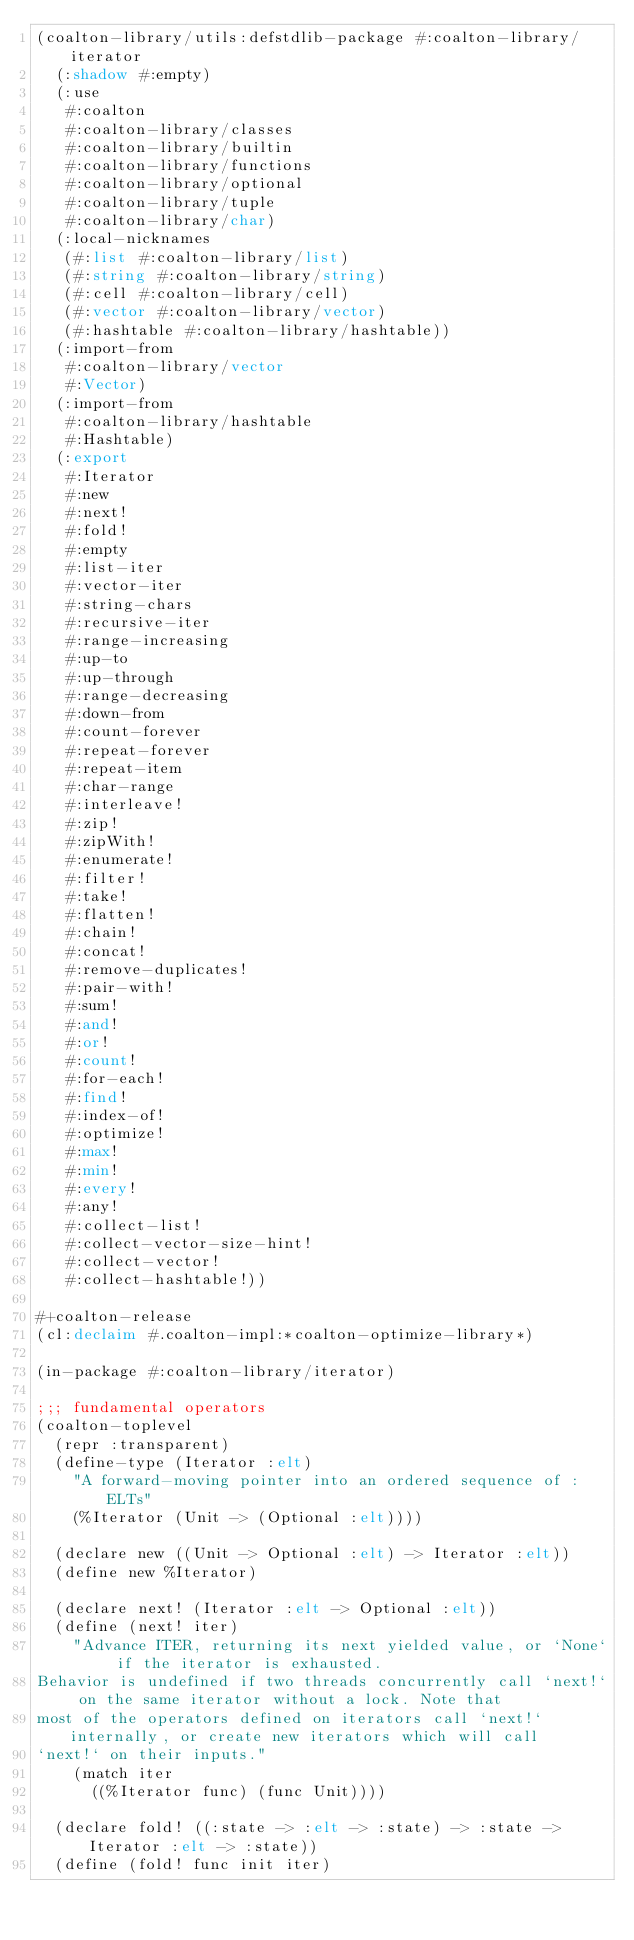<code> <loc_0><loc_0><loc_500><loc_500><_Lisp_>(coalton-library/utils:defstdlib-package #:coalton-library/iterator
  (:shadow #:empty)
  (:use
   #:coalton
   #:coalton-library/classes
   #:coalton-library/builtin
   #:coalton-library/functions
   #:coalton-library/optional
   #:coalton-library/tuple
   #:coalton-library/char)
  (:local-nicknames
   (#:list #:coalton-library/list)
   (#:string #:coalton-library/string)
   (#:cell #:coalton-library/cell)
   (#:vector #:coalton-library/vector)
   (#:hashtable #:coalton-library/hashtable))
  (:import-from
   #:coalton-library/vector
   #:Vector)
  (:import-from
   #:coalton-library/hashtable
   #:Hashtable)
  (:export
   #:Iterator
   #:new
   #:next!
   #:fold!
   #:empty
   #:list-iter
   #:vector-iter
   #:string-chars
   #:recursive-iter
   #:range-increasing
   #:up-to
   #:up-through
   #:range-decreasing
   #:down-from
   #:count-forever
   #:repeat-forever
   #:repeat-item
   #:char-range
   #:interleave!
   #:zip!
   #:zipWith!
   #:enumerate!
   #:filter!
   #:take!
   #:flatten!
   #:chain!
   #:concat!
   #:remove-duplicates!
   #:pair-with!
   #:sum!
   #:and!
   #:or!
   #:count!
   #:for-each!
   #:find!
   #:index-of!
   #:optimize!
   #:max!
   #:min!
   #:every!
   #:any!
   #:collect-list!
   #:collect-vector-size-hint!
   #:collect-vector!
   #:collect-hashtable!))

#+coalton-release
(cl:declaim #.coalton-impl:*coalton-optimize-library*)

(in-package #:coalton-library/iterator)

;;; fundamental operators
(coalton-toplevel
  (repr :transparent)
  (define-type (Iterator :elt)
    "A forward-moving pointer into an ordered sequence of :ELTs"
    (%Iterator (Unit -> (Optional :elt))))

  (declare new ((Unit -> Optional :elt) -> Iterator :elt))
  (define new %Iterator)

  (declare next! (Iterator :elt -> Optional :elt))
  (define (next! iter)
    "Advance ITER, returning its next yielded value, or `None` if the iterator is exhausted.
Behavior is undefined if two threads concurrently call `next!` on the same iterator without a lock. Note that
most of the operators defined on iterators call `next!` internally, or create new iterators which will call
`next!` on their inputs."
    (match iter
      ((%Iterator func) (func Unit))))

  (declare fold! ((:state -> :elt -> :state) -> :state -> Iterator :elt -> :state))
  (define (fold! func init iter)</code> 